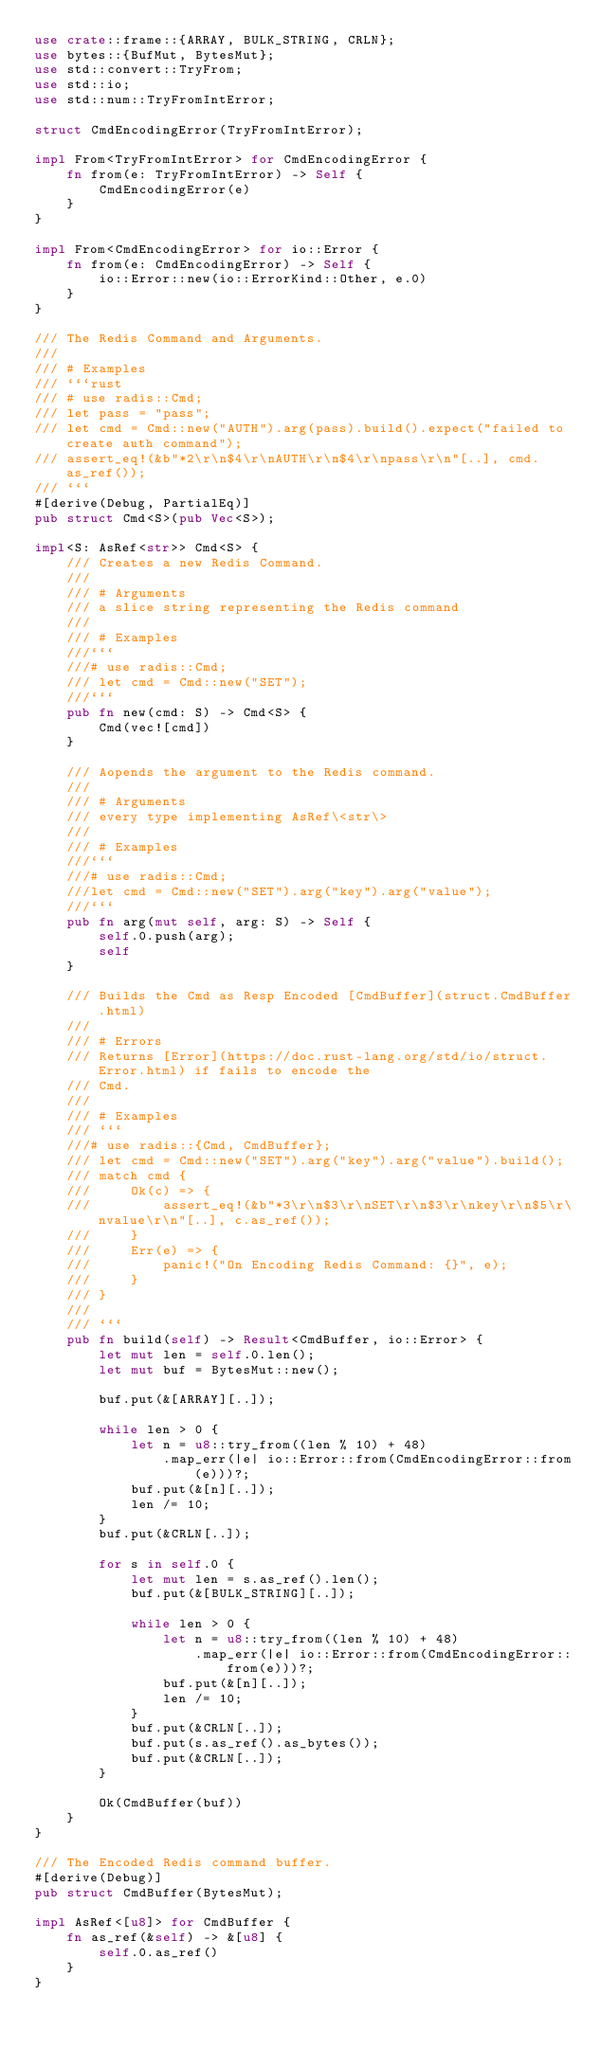Convert code to text. <code><loc_0><loc_0><loc_500><loc_500><_Rust_>use crate::frame::{ARRAY, BULK_STRING, CRLN};
use bytes::{BufMut, BytesMut};
use std::convert::TryFrom;
use std::io;
use std::num::TryFromIntError;

struct CmdEncodingError(TryFromIntError);

impl From<TryFromIntError> for CmdEncodingError {
    fn from(e: TryFromIntError) -> Self {
        CmdEncodingError(e)
    }
}

impl From<CmdEncodingError> for io::Error {
    fn from(e: CmdEncodingError) -> Self {
        io::Error::new(io::ErrorKind::Other, e.0)
    }
}

/// The Redis Command and Arguments.
///
/// # Examples
/// ```rust
/// # use radis::Cmd;
/// let pass = "pass";
/// let cmd = Cmd::new("AUTH").arg(pass).build().expect("failed to create auth command");
/// assert_eq!(&b"*2\r\n$4\r\nAUTH\r\n$4\r\npass\r\n"[..], cmd.as_ref());
/// ```
#[derive(Debug, PartialEq)]
pub struct Cmd<S>(pub Vec<S>);

impl<S: AsRef<str>> Cmd<S> {
    /// Creates a new Redis Command.
    ///
    /// # Arguments
    /// a slice string representing the Redis command
    ///
    /// # Examples
    ///```
    ///# use radis::Cmd;
    /// let cmd = Cmd::new("SET");
    ///```
    pub fn new(cmd: S) -> Cmd<S> {
        Cmd(vec![cmd])
    }

    /// Aopends the argument to the Redis command.
    ///
    /// # Arguments
    /// every type implementing AsRef\<str\>
    ///
    /// # Examples
    ///```
    ///# use radis::Cmd;
    ///let cmd = Cmd::new("SET").arg("key").arg("value");
    ///```
    pub fn arg(mut self, arg: S) -> Self {
        self.0.push(arg);
        self
    }

    /// Builds the Cmd as Resp Encoded [CmdBuffer](struct.CmdBuffer.html)
    ///
    /// # Errors
    /// Returns [Error](https://doc.rust-lang.org/std/io/struct.Error.html) if fails to encode the
    /// Cmd.
    ///
    /// # Examples
    /// ```
    ///# use radis::{Cmd, CmdBuffer};
    /// let cmd = Cmd::new("SET").arg("key").arg("value").build();
    /// match cmd {
    ///     Ok(c) => {
    ///         assert_eq!(&b"*3\r\n$3\r\nSET\r\n$3\r\nkey\r\n$5\r\nvalue\r\n"[..], c.as_ref());
    ///     }
    ///     Err(e) => {
    ///         panic!("On Encoding Redis Command: {}", e);
    ///     }
    /// }
    ///
    /// ```
    pub fn build(self) -> Result<CmdBuffer, io::Error> {
        let mut len = self.0.len();
        let mut buf = BytesMut::new();

        buf.put(&[ARRAY][..]);

        while len > 0 {
            let n = u8::try_from((len % 10) + 48)
                .map_err(|e| io::Error::from(CmdEncodingError::from(e)))?;
            buf.put(&[n][..]);
            len /= 10;
        }
        buf.put(&CRLN[..]);

        for s in self.0 {
            let mut len = s.as_ref().len();
            buf.put(&[BULK_STRING][..]);

            while len > 0 {
                let n = u8::try_from((len % 10) + 48)
                    .map_err(|e| io::Error::from(CmdEncodingError::from(e)))?;
                buf.put(&[n][..]);
                len /= 10;
            }
            buf.put(&CRLN[..]);
            buf.put(s.as_ref().as_bytes());
            buf.put(&CRLN[..]);
        }

        Ok(CmdBuffer(buf))
    }
}

/// The Encoded Redis command buffer.
#[derive(Debug)]
pub struct CmdBuffer(BytesMut);

impl AsRef<[u8]> for CmdBuffer {
    fn as_ref(&self) -> &[u8] {
        self.0.as_ref()
    }
}
</code> 